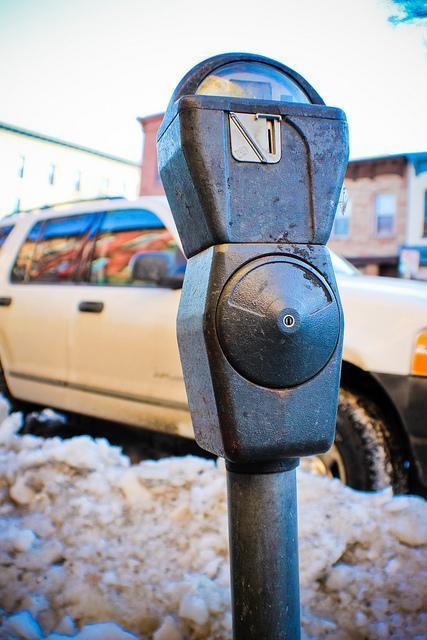How many meters are in the photo?
Give a very brief answer. 1. How many people are wearing a tie?
Give a very brief answer. 0. 